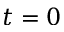<formula> <loc_0><loc_0><loc_500><loc_500>t = 0</formula> 